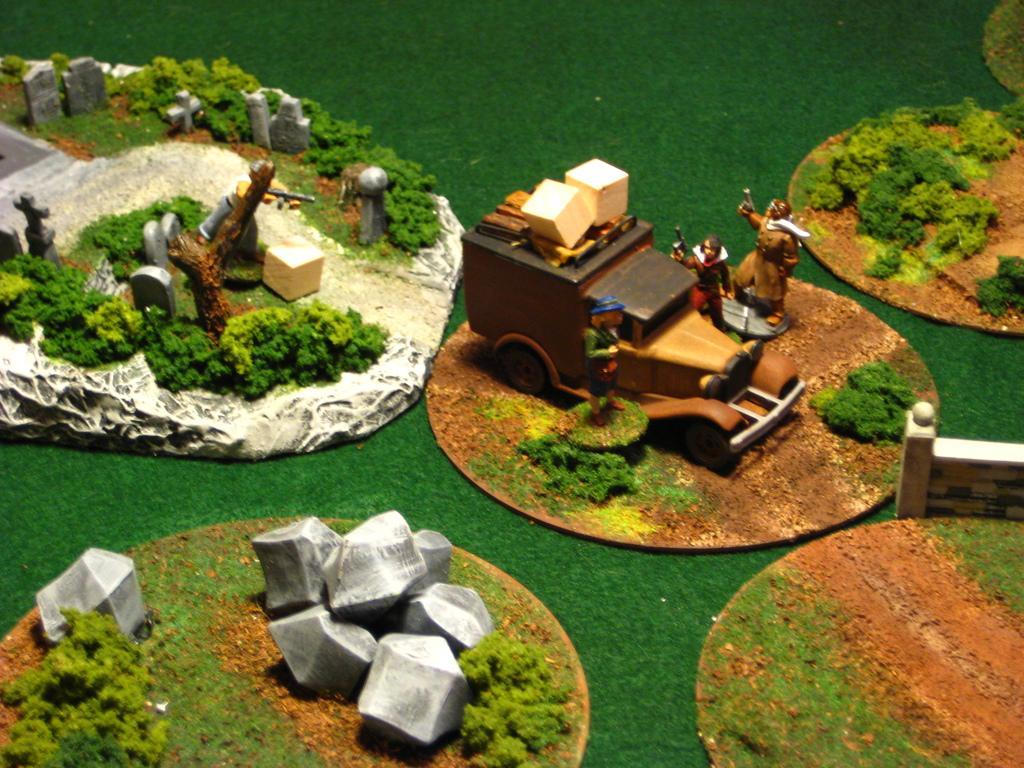In one or two sentences, can you explain what this image depicts? In this image there are objects which are on the plates and there are stones in the front. In the center there is a toy car and there are puppets and there are plants and there is a green mat which is visible. 